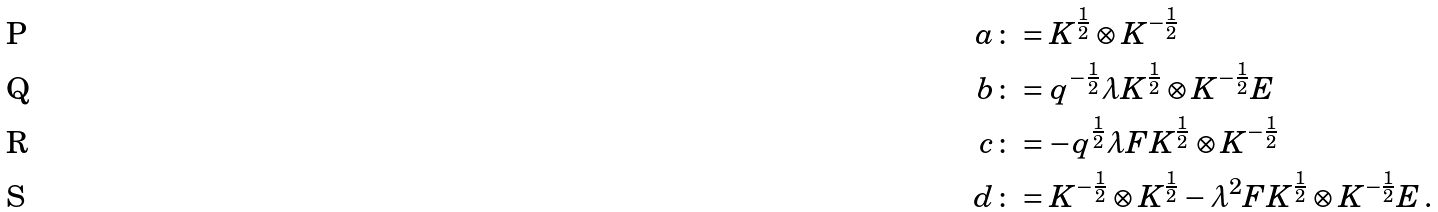Convert formula to latex. <formula><loc_0><loc_0><loc_500><loc_500>a & \colon = K ^ { \frac { 1 } { 2 } } \otimes K ^ { - \frac { 1 } { 2 } } \\ b & \colon = q ^ { - \frac { 1 } { 2 } } \lambda K ^ { \frac { 1 } { 2 } } \otimes K ^ { - \frac { 1 } { 2 } } E \\ c & \colon = - q ^ { \frac { 1 } { 2 } } \lambda F K ^ { \frac { 1 } { 2 } } \otimes K ^ { - \frac { 1 } { 2 } } \\ d & \colon = K ^ { - \frac { 1 } { 2 } } \otimes K ^ { \frac { 1 } { 2 } } - \lambda ^ { 2 } F K ^ { \frac { 1 } { 2 } } \otimes K ^ { - \frac { 1 } { 2 } } E \, .</formula> 